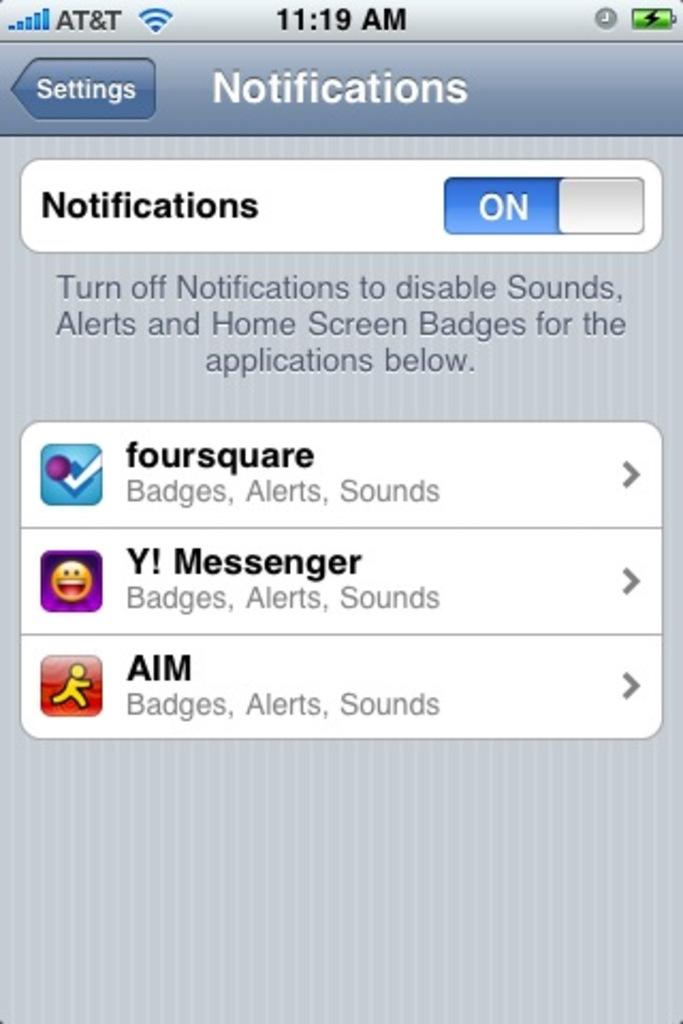What are notifications set to?
Your answer should be compact. On. Do they have an aim app?
Your answer should be compact. Yes. 